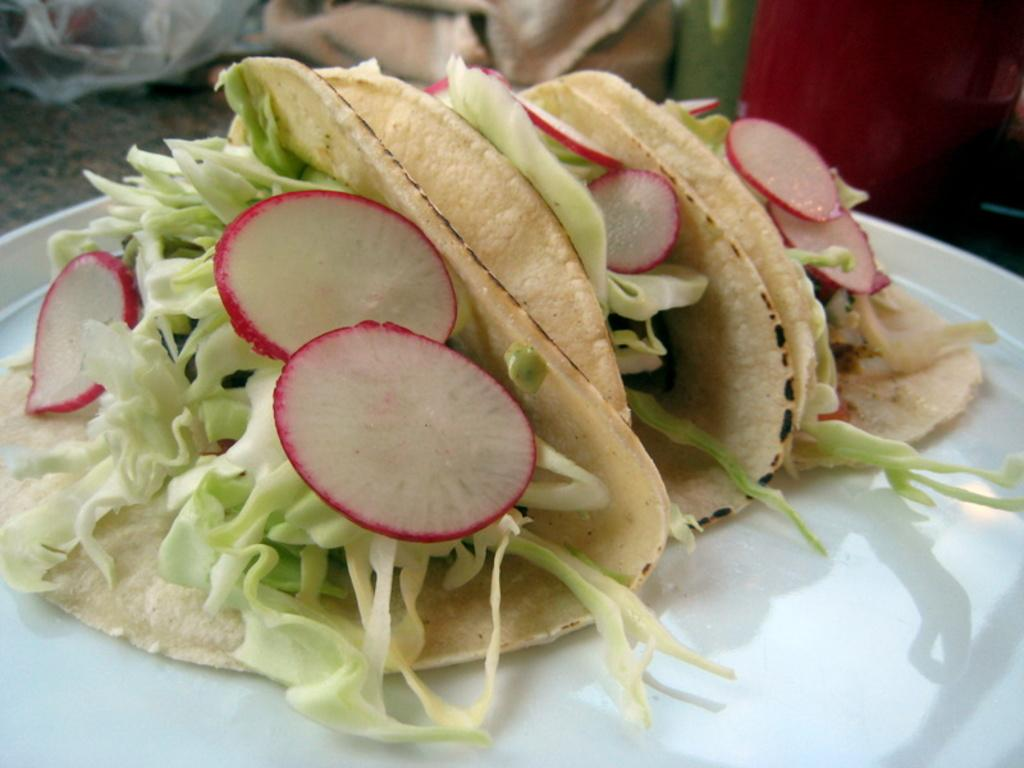What type of vegetable is present in the image? There is chopped cabbage in the image. What fruit is also visible in the image? There are strawberries in the image. How are the cabbage and strawberries arranged in the image? The cabbage and strawberries are planted in rotis. On what surface are the food items placed? The food items are placed on a white plate. What type of bells can be heard ringing in the image? There are no bells present in the image, and therefore no sounds can be heard. 